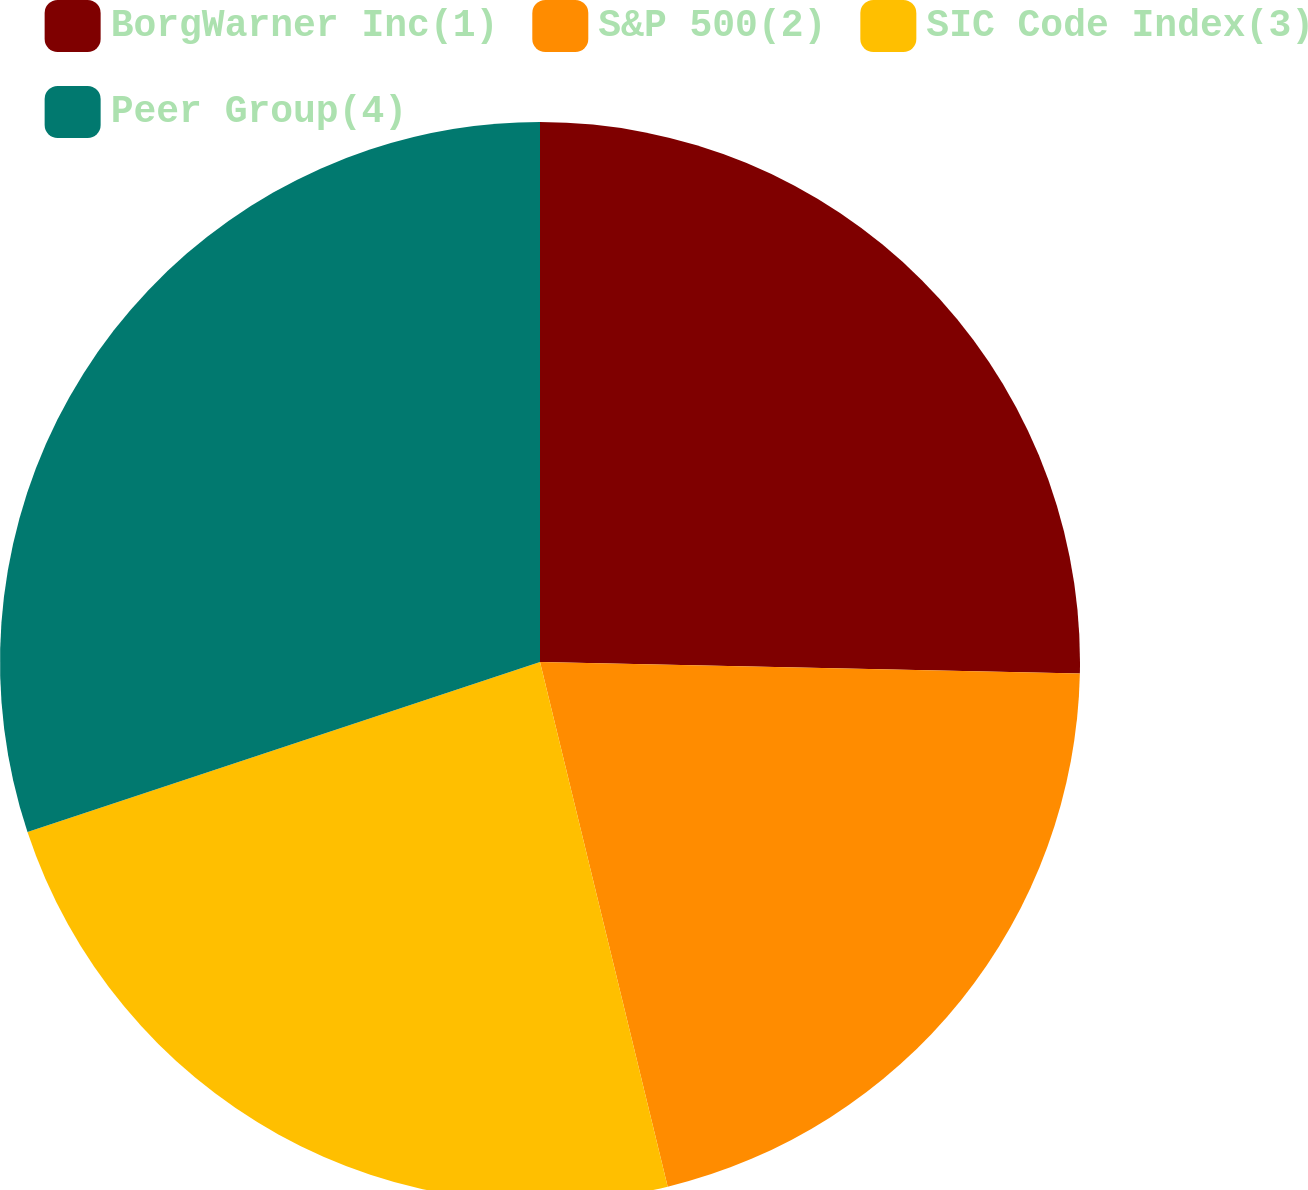Convert chart. <chart><loc_0><loc_0><loc_500><loc_500><pie_chart><fcel>BorgWarner Inc(1)<fcel>S&P 500(2)<fcel>SIC Code Index(3)<fcel>Peer Group(4)<nl><fcel>25.34%<fcel>20.86%<fcel>23.7%<fcel>30.1%<nl></chart> 